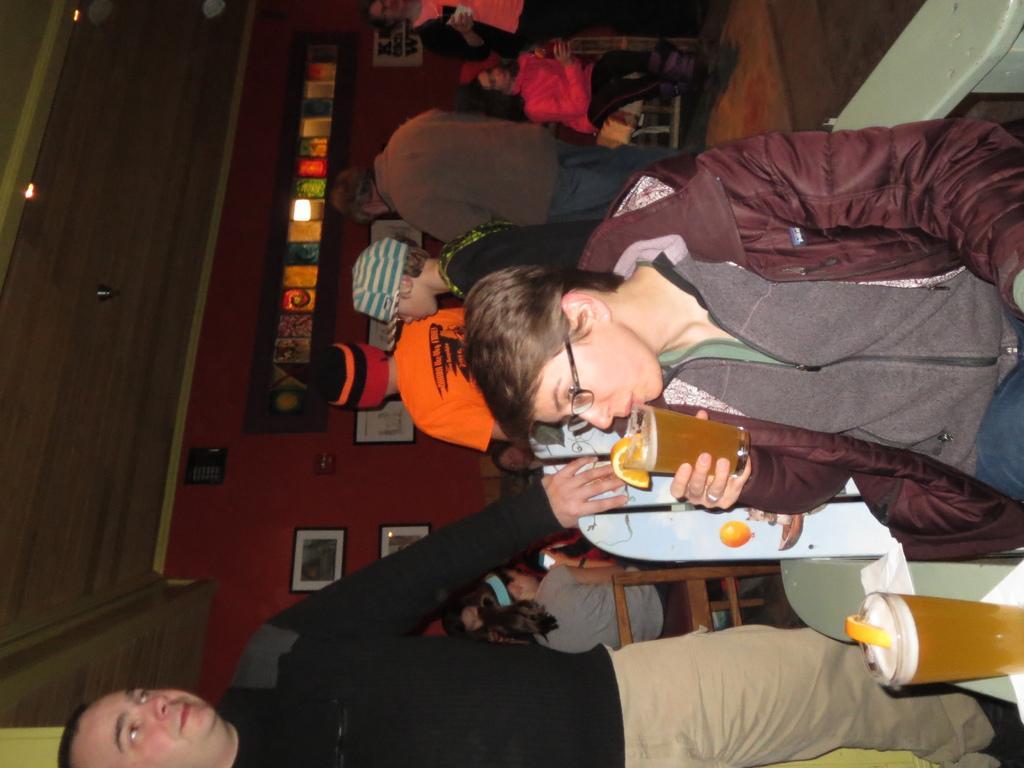In one or two sentences, can you explain what this image depicts? In this image I see number of people in which few of them are sitting and I see that this woman is holding a glass near to her mouth and I see another glass over here. In the background I see the wall and I see 2 photo frames over here and I see the ceiling. 